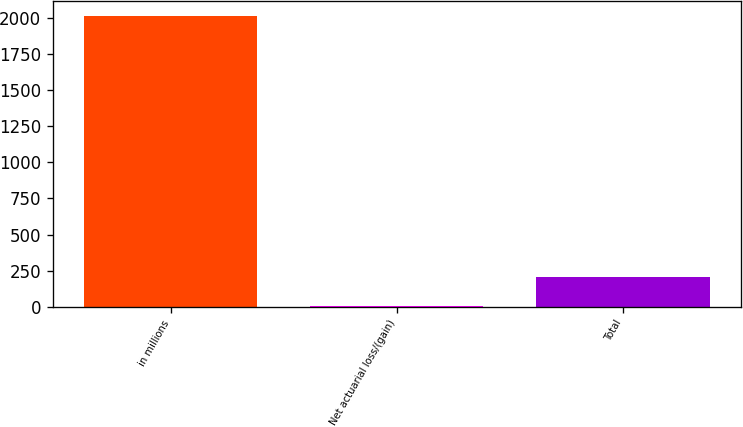Convert chart. <chart><loc_0><loc_0><loc_500><loc_500><bar_chart><fcel>in millions<fcel>Net actuarial loss/(gain)<fcel>Total<nl><fcel>2015<fcel>8.4<fcel>209.06<nl></chart> 